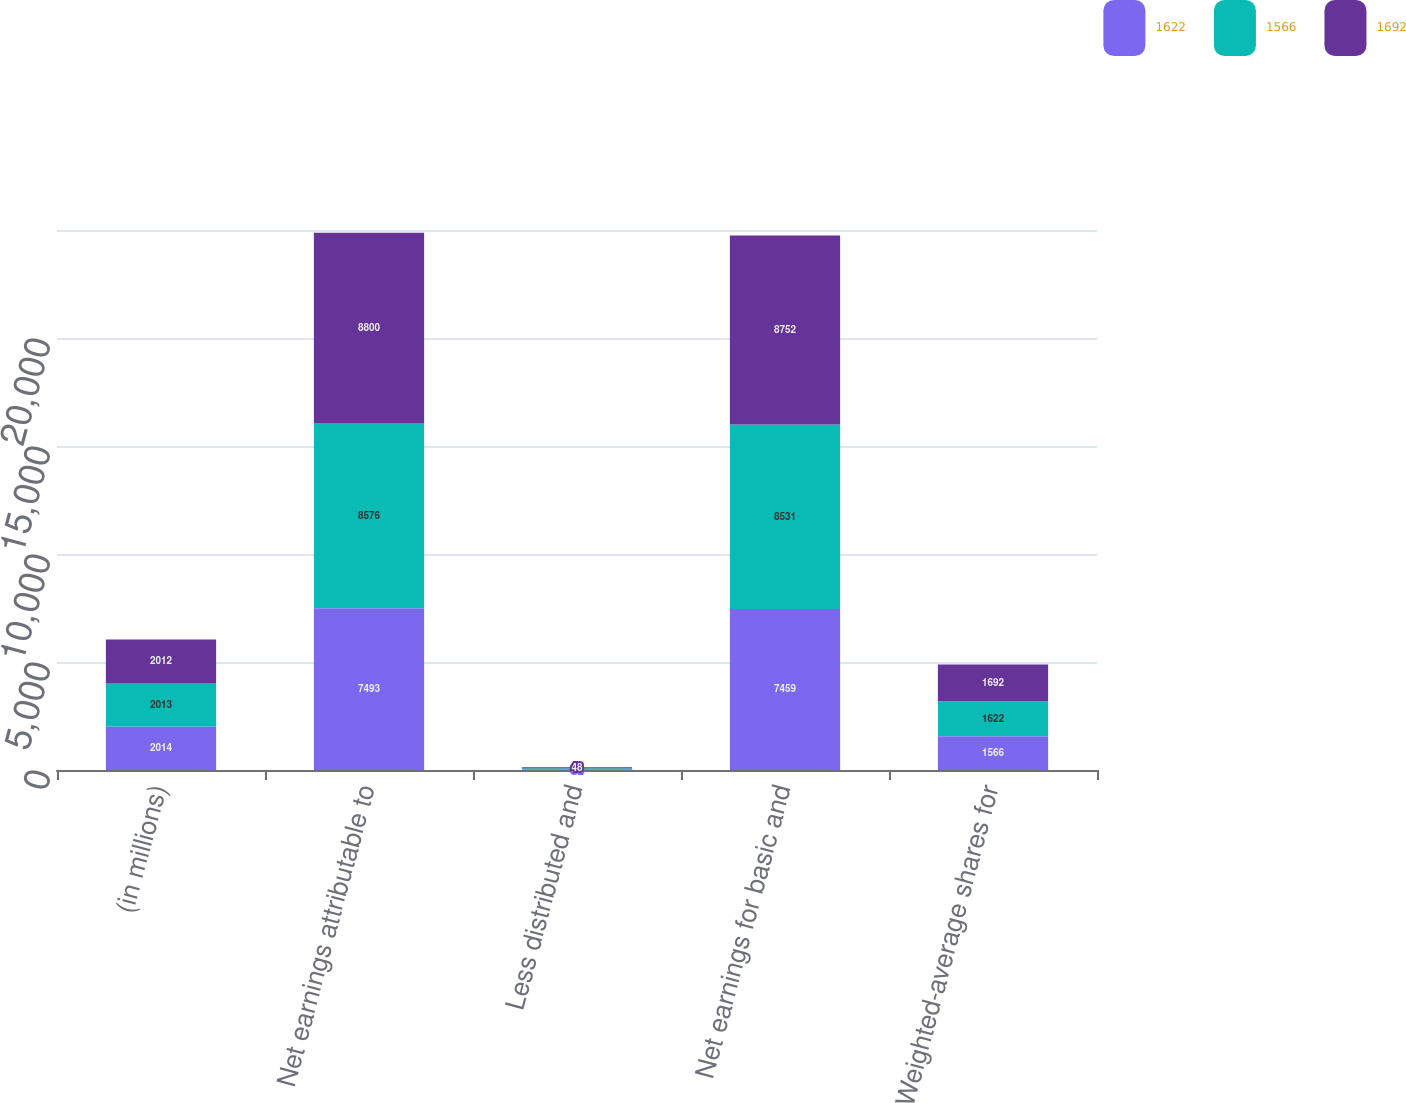Convert chart. <chart><loc_0><loc_0><loc_500><loc_500><stacked_bar_chart><ecel><fcel>(in millions)<fcel>Net earnings attributable to<fcel>Less distributed and<fcel>Net earnings for basic and<fcel>Weighted-average shares for<nl><fcel>1622<fcel>2014<fcel>7493<fcel>34<fcel>7459<fcel>1566<nl><fcel>1566<fcel>2013<fcel>8576<fcel>45<fcel>8531<fcel>1622<nl><fcel>1692<fcel>2012<fcel>8800<fcel>48<fcel>8752<fcel>1692<nl></chart> 